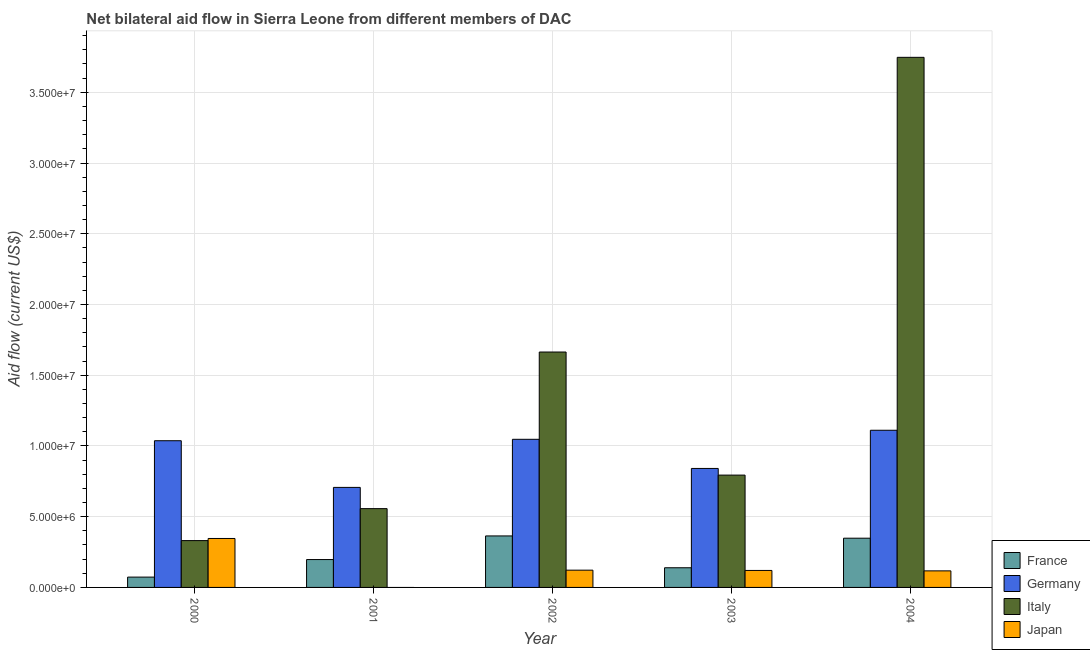How many groups of bars are there?
Ensure brevity in your answer.  5. Are the number of bars on each tick of the X-axis equal?
Your answer should be compact. No. How many bars are there on the 1st tick from the left?
Provide a short and direct response. 4. How many bars are there on the 5th tick from the right?
Make the answer very short. 4. What is the label of the 1st group of bars from the left?
Offer a very short reply. 2000. What is the amount of aid given by germany in 2003?
Offer a terse response. 8.41e+06. Across all years, what is the maximum amount of aid given by italy?
Give a very brief answer. 3.75e+07. Across all years, what is the minimum amount of aid given by italy?
Provide a succinct answer. 3.31e+06. In which year was the amount of aid given by japan maximum?
Your answer should be compact. 2000. What is the total amount of aid given by france in the graph?
Offer a very short reply. 1.12e+07. What is the difference between the amount of aid given by germany in 2002 and that in 2003?
Provide a short and direct response. 2.06e+06. What is the difference between the amount of aid given by japan in 2003 and the amount of aid given by france in 2002?
Offer a terse response. -2.00e+04. What is the average amount of aid given by italy per year?
Offer a terse response. 1.42e+07. In the year 2003, what is the difference between the amount of aid given by japan and amount of aid given by germany?
Your answer should be very brief. 0. What is the ratio of the amount of aid given by france in 2000 to that in 2004?
Offer a very short reply. 0.21. Is the amount of aid given by germany in 2003 less than that in 2004?
Provide a short and direct response. Yes. What is the difference between the highest and the second highest amount of aid given by italy?
Offer a very short reply. 2.08e+07. What is the difference between the highest and the lowest amount of aid given by japan?
Offer a terse response. 3.46e+06. Is it the case that in every year, the sum of the amount of aid given by france and amount of aid given by germany is greater than the amount of aid given by italy?
Your answer should be very brief. No. How many bars are there?
Give a very brief answer. 19. Are all the bars in the graph horizontal?
Your answer should be very brief. No. Does the graph contain any zero values?
Keep it short and to the point. Yes. Does the graph contain grids?
Keep it short and to the point. Yes. Where does the legend appear in the graph?
Your response must be concise. Bottom right. How many legend labels are there?
Keep it short and to the point. 4. What is the title of the graph?
Provide a succinct answer. Net bilateral aid flow in Sierra Leone from different members of DAC. What is the label or title of the X-axis?
Offer a terse response. Year. What is the Aid flow (current US$) of France in 2000?
Provide a short and direct response. 7.30e+05. What is the Aid flow (current US$) in Germany in 2000?
Provide a succinct answer. 1.04e+07. What is the Aid flow (current US$) of Italy in 2000?
Provide a succinct answer. 3.31e+06. What is the Aid flow (current US$) of Japan in 2000?
Give a very brief answer. 3.46e+06. What is the Aid flow (current US$) of France in 2001?
Offer a terse response. 1.97e+06. What is the Aid flow (current US$) of Germany in 2001?
Ensure brevity in your answer.  7.07e+06. What is the Aid flow (current US$) of Italy in 2001?
Your answer should be compact. 5.57e+06. What is the Aid flow (current US$) in France in 2002?
Ensure brevity in your answer.  3.64e+06. What is the Aid flow (current US$) of Germany in 2002?
Your response must be concise. 1.05e+07. What is the Aid flow (current US$) of Italy in 2002?
Your answer should be compact. 1.66e+07. What is the Aid flow (current US$) in Japan in 2002?
Your response must be concise. 1.22e+06. What is the Aid flow (current US$) in France in 2003?
Offer a very short reply. 1.39e+06. What is the Aid flow (current US$) in Germany in 2003?
Your answer should be compact. 8.41e+06. What is the Aid flow (current US$) of Italy in 2003?
Offer a very short reply. 7.94e+06. What is the Aid flow (current US$) of Japan in 2003?
Your response must be concise. 1.20e+06. What is the Aid flow (current US$) in France in 2004?
Make the answer very short. 3.48e+06. What is the Aid flow (current US$) in Germany in 2004?
Your response must be concise. 1.11e+07. What is the Aid flow (current US$) in Italy in 2004?
Make the answer very short. 3.75e+07. What is the Aid flow (current US$) of Japan in 2004?
Provide a succinct answer. 1.17e+06. Across all years, what is the maximum Aid flow (current US$) in France?
Ensure brevity in your answer.  3.64e+06. Across all years, what is the maximum Aid flow (current US$) in Germany?
Give a very brief answer. 1.11e+07. Across all years, what is the maximum Aid flow (current US$) of Italy?
Your response must be concise. 3.75e+07. Across all years, what is the maximum Aid flow (current US$) of Japan?
Your response must be concise. 3.46e+06. Across all years, what is the minimum Aid flow (current US$) in France?
Give a very brief answer. 7.30e+05. Across all years, what is the minimum Aid flow (current US$) of Germany?
Offer a terse response. 7.07e+06. Across all years, what is the minimum Aid flow (current US$) in Italy?
Provide a short and direct response. 3.31e+06. Across all years, what is the minimum Aid flow (current US$) of Japan?
Your answer should be compact. 0. What is the total Aid flow (current US$) in France in the graph?
Offer a very short reply. 1.12e+07. What is the total Aid flow (current US$) in Germany in the graph?
Your response must be concise. 4.74e+07. What is the total Aid flow (current US$) of Italy in the graph?
Your response must be concise. 7.09e+07. What is the total Aid flow (current US$) of Japan in the graph?
Keep it short and to the point. 7.05e+06. What is the difference between the Aid flow (current US$) of France in 2000 and that in 2001?
Make the answer very short. -1.24e+06. What is the difference between the Aid flow (current US$) of Germany in 2000 and that in 2001?
Your response must be concise. 3.30e+06. What is the difference between the Aid flow (current US$) of Italy in 2000 and that in 2001?
Provide a succinct answer. -2.26e+06. What is the difference between the Aid flow (current US$) in France in 2000 and that in 2002?
Your response must be concise. -2.91e+06. What is the difference between the Aid flow (current US$) in Italy in 2000 and that in 2002?
Keep it short and to the point. -1.33e+07. What is the difference between the Aid flow (current US$) in Japan in 2000 and that in 2002?
Provide a succinct answer. 2.24e+06. What is the difference between the Aid flow (current US$) of France in 2000 and that in 2003?
Make the answer very short. -6.60e+05. What is the difference between the Aid flow (current US$) in Germany in 2000 and that in 2003?
Your response must be concise. 1.96e+06. What is the difference between the Aid flow (current US$) in Italy in 2000 and that in 2003?
Your response must be concise. -4.63e+06. What is the difference between the Aid flow (current US$) in Japan in 2000 and that in 2003?
Offer a very short reply. 2.26e+06. What is the difference between the Aid flow (current US$) of France in 2000 and that in 2004?
Ensure brevity in your answer.  -2.75e+06. What is the difference between the Aid flow (current US$) in Germany in 2000 and that in 2004?
Ensure brevity in your answer.  -7.40e+05. What is the difference between the Aid flow (current US$) in Italy in 2000 and that in 2004?
Give a very brief answer. -3.42e+07. What is the difference between the Aid flow (current US$) of Japan in 2000 and that in 2004?
Your answer should be compact. 2.29e+06. What is the difference between the Aid flow (current US$) in France in 2001 and that in 2002?
Keep it short and to the point. -1.67e+06. What is the difference between the Aid flow (current US$) of Germany in 2001 and that in 2002?
Make the answer very short. -3.40e+06. What is the difference between the Aid flow (current US$) in Italy in 2001 and that in 2002?
Your answer should be compact. -1.11e+07. What is the difference between the Aid flow (current US$) in France in 2001 and that in 2003?
Your answer should be compact. 5.80e+05. What is the difference between the Aid flow (current US$) of Germany in 2001 and that in 2003?
Make the answer very short. -1.34e+06. What is the difference between the Aid flow (current US$) of Italy in 2001 and that in 2003?
Give a very brief answer. -2.37e+06. What is the difference between the Aid flow (current US$) in France in 2001 and that in 2004?
Give a very brief answer. -1.51e+06. What is the difference between the Aid flow (current US$) of Germany in 2001 and that in 2004?
Make the answer very short. -4.04e+06. What is the difference between the Aid flow (current US$) in Italy in 2001 and that in 2004?
Make the answer very short. -3.19e+07. What is the difference between the Aid flow (current US$) of France in 2002 and that in 2003?
Your answer should be very brief. 2.25e+06. What is the difference between the Aid flow (current US$) of Germany in 2002 and that in 2003?
Your answer should be very brief. 2.06e+06. What is the difference between the Aid flow (current US$) of Italy in 2002 and that in 2003?
Your answer should be very brief. 8.70e+06. What is the difference between the Aid flow (current US$) in Japan in 2002 and that in 2003?
Give a very brief answer. 2.00e+04. What is the difference between the Aid flow (current US$) in France in 2002 and that in 2004?
Offer a very short reply. 1.60e+05. What is the difference between the Aid flow (current US$) in Germany in 2002 and that in 2004?
Ensure brevity in your answer.  -6.40e+05. What is the difference between the Aid flow (current US$) of Italy in 2002 and that in 2004?
Offer a very short reply. -2.08e+07. What is the difference between the Aid flow (current US$) in Japan in 2002 and that in 2004?
Provide a succinct answer. 5.00e+04. What is the difference between the Aid flow (current US$) of France in 2003 and that in 2004?
Provide a short and direct response. -2.09e+06. What is the difference between the Aid flow (current US$) in Germany in 2003 and that in 2004?
Your response must be concise. -2.70e+06. What is the difference between the Aid flow (current US$) in Italy in 2003 and that in 2004?
Ensure brevity in your answer.  -2.95e+07. What is the difference between the Aid flow (current US$) in France in 2000 and the Aid flow (current US$) in Germany in 2001?
Provide a short and direct response. -6.34e+06. What is the difference between the Aid flow (current US$) in France in 2000 and the Aid flow (current US$) in Italy in 2001?
Offer a terse response. -4.84e+06. What is the difference between the Aid flow (current US$) in Germany in 2000 and the Aid flow (current US$) in Italy in 2001?
Your response must be concise. 4.80e+06. What is the difference between the Aid flow (current US$) of France in 2000 and the Aid flow (current US$) of Germany in 2002?
Make the answer very short. -9.74e+06. What is the difference between the Aid flow (current US$) in France in 2000 and the Aid flow (current US$) in Italy in 2002?
Keep it short and to the point. -1.59e+07. What is the difference between the Aid flow (current US$) in France in 2000 and the Aid flow (current US$) in Japan in 2002?
Provide a succinct answer. -4.90e+05. What is the difference between the Aid flow (current US$) in Germany in 2000 and the Aid flow (current US$) in Italy in 2002?
Make the answer very short. -6.27e+06. What is the difference between the Aid flow (current US$) of Germany in 2000 and the Aid flow (current US$) of Japan in 2002?
Your response must be concise. 9.15e+06. What is the difference between the Aid flow (current US$) of Italy in 2000 and the Aid flow (current US$) of Japan in 2002?
Offer a terse response. 2.09e+06. What is the difference between the Aid flow (current US$) of France in 2000 and the Aid flow (current US$) of Germany in 2003?
Your answer should be compact. -7.68e+06. What is the difference between the Aid flow (current US$) of France in 2000 and the Aid flow (current US$) of Italy in 2003?
Your response must be concise. -7.21e+06. What is the difference between the Aid flow (current US$) of France in 2000 and the Aid flow (current US$) of Japan in 2003?
Keep it short and to the point. -4.70e+05. What is the difference between the Aid flow (current US$) of Germany in 2000 and the Aid flow (current US$) of Italy in 2003?
Your response must be concise. 2.43e+06. What is the difference between the Aid flow (current US$) in Germany in 2000 and the Aid flow (current US$) in Japan in 2003?
Your response must be concise. 9.17e+06. What is the difference between the Aid flow (current US$) of Italy in 2000 and the Aid flow (current US$) of Japan in 2003?
Ensure brevity in your answer.  2.11e+06. What is the difference between the Aid flow (current US$) of France in 2000 and the Aid flow (current US$) of Germany in 2004?
Offer a terse response. -1.04e+07. What is the difference between the Aid flow (current US$) of France in 2000 and the Aid flow (current US$) of Italy in 2004?
Your response must be concise. -3.67e+07. What is the difference between the Aid flow (current US$) in France in 2000 and the Aid flow (current US$) in Japan in 2004?
Ensure brevity in your answer.  -4.40e+05. What is the difference between the Aid flow (current US$) of Germany in 2000 and the Aid flow (current US$) of Italy in 2004?
Keep it short and to the point. -2.71e+07. What is the difference between the Aid flow (current US$) of Germany in 2000 and the Aid flow (current US$) of Japan in 2004?
Provide a short and direct response. 9.20e+06. What is the difference between the Aid flow (current US$) of Italy in 2000 and the Aid flow (current US$) of Japan in 2004?
Your response must be concise. 2.14e+06. What is the difference between the Aid flow (current US$) of France in 2001 and the Aid flow (current US$) of Germany in 2002?
Make the answer very short. -8.50e+06. What is the difference between the Aid flow (current US$) of France in 2001 and the Aid flow (current US$) of Italy in 2002?
Give a very brief answer. -1.47e+07. What is the difference between the Aid flow (current US$) in France in 2001 and the Aid flow (current US$) in Japan in 2002?
Keep it short and to the point. 7.50e+05. What is the difference between the Aid flow (current US$) of Germany in 2001 and the Aid flow (current US$) of Italy in 2002?
Provide a succinct answer. -9.57e+06. What is the difference between the Aid flow (current US$) of Germany in 2001 and the Aid flow (current US$) of Japan in 2002?
Offer a terse response. 5.85e+06. What is the difference between the Aid flow (current US$) in Italy in 2001 and the Aid flow (current US$) in Japan in 2002?
Make the answer very short. 4.35e+06. What is the difference between the Aid flow (current US$) of France in 2001 and the Aid flow (current US$) of Germany in 2003?
Your answer should be compact. -6.44e+06. What is the difference between the Aid flow (current US$) of France in 2001 and the Aid flow (current US$) of Italy in 2003?
Ensure brevity in your answer.  -5.97e+06. What is the difference between the Aid flow (current US$) in France in 2001 and the Aid flow (current US$) in Japan in 2003?
Keep it short and to the point. 7.70e+05. What is the difference between the Aid flow (current US$) of Germany in 2001 and the Aid flow (current US$) of Italy in 2003?
Give a very brief answer. -8.70e+05. What is the difference between the Aid flow (current US$) in Germany in 2001 and the Aid flow (current US$) in Japan in 2003?
Your answer should be compact. 5.87e+06. What is the difference between the Aid flow (current US$) in Italy in 2001 and the Aid flow (current US$) in Japan in 2003?
Your answer should be compact. 4.37e+06. What is the difference between the Aid flow (current US$) of France in 2001 and the Aid flow (current US$) of Germany in 2004?
Your answer should be very brief. -9.14e+06. What is the difference between the Aid flow (current US$) of France in 2001 and the Aid flow (current US$) of Italy in 2004?
Your response must be concise. -3.55e+07. What is the difference between the Aid flow (current US$) in France in 2001 and the Aid flow (current US$) in Japan in 2004?
Make the answer very short. 8.00e+05. What is the difference between the Aid flow (current US$) of Germany in 2001 and the Aid flow (current US$) of Italy in 2004?
Your answer should be very brief. -3.04e+07. What is the difference between the Aid flow (current US$) in Germany in 2001 and the Aid flow (current US$) in Japan in 2004?
Make the answer very short. 5.90e+06. What is the difference between the Aid flow (current US$) of Italy in 2001 and the Aid flow (current US$) of Japan in 2004?
Your response must be concise. 4.40e+06. What is the difference between the Aid flow (current US$) in France in 2002 and the Aid flow (current US$) in Germany in 2003?
Make the answer very short. -4.77e+06. What is the difference between the Aid flow (current US$) in France in 2002 and the Aid flow (current US$) in Italy in 2003?
Keep it short and to the point. -4.30e+06. What is the difference between the Aid flow (current US$) of France in 2002 and the Aid flow (current US$) of Japan in 2003?
Keep it short and to the point. 2.44e+06. What is the difference between the Aid flow (current US$) in Germany in 2002 and the Aid flow (current US$) in Italy in 2003?
Give a very brief answer. 2.53e+06. What is the difference between the Aid flow (current US$) of Germany in 2002 and the Aid flow (current US$) of Japan in 2003?
Your answer should be very brief. 9.27e+06. What is the difference between the Aid flow (current US$) of Italy in 2002 and the Aid flow (current US$) of Japan in 2003?
Ensure brevity in your answer.  1.54e+07. What is the difference between the Aid flow (current US$) in France in 2002 and the Aid flow (current US$) in Germany in 2004?
Offer a very short reply. -7.47e+06. What is the difference between the Aid flow (current US$) in France in 2002 and the Aid flow (current US$) in Italy in 2004?
Give a very brief answer. -3.38e+07. What is the difference between the Aid flow (current US$) of France in 2002 and the Aid flow (current US$) of Japan in 2004?
Your answer should be very brief. 2.47e+06. What is the difference between the Aid flow (current US$) of Germany in 2002 and the Aid flow (current US$) of Italy in 2004?
Ensure brevity in your answer.  -2.70e+07. What is the difference between the Aid flow (current US$) of Germany in 2002 and the Aid flow (current US$) of Japan in 2004?
Provide a short and direct response. 9.30e+06. What is the difference between the Aid flow (current US$) of Italy in 2002 and the Aid flow (current US$) of Japan in 2004?
Give a very brief answer. 1.55e+07. What is the difference between the Aid flow (current US$) of France in 2003 and the Aid flow (current US$) of Germany in 2004?
Provide a short and direct response. -9.72e+06. What is the difference between the Aid flow (current US$) in France in 2003 and the Aid flow (current US$) in Italy in 2004?
Offer a very short reply. -3.61e+07. What is the difference between the Aid flow (current US$) in France in 2003 and the Aid flow (current US$) in Japan in 2004?
Give a very brief answer. 2.20e+05. What is the difference between the Aid flow (current US$) of Germany in 2003 and the Aid flow (current US$) of Italy in 2004?
Ensure brevity in your answer.  -2.91e+07. What is the difference between the Aid flow (current US$) in Germany in 2003 and the Aid flow (current US$) in Japan in 2004?
Offer a very short reply. 7.24e+06. What is the difference between the Aid flow (current US$) in Italy in 2003 and the Aid flow (current US$) in Japan in 2004?
Your response must be concise. 6.77e+06. What is the average Aid flow (current US$) of France per year?
Give a very brief answer. 2.24e+06. What is the average Aid flow (current US$) in Germany per year?
Give a very brief answer. 9.49e+06. What is the average Aid flow (current US$) of Italy per year?
Offer a very short reply. 1.42e+07. What is the average Aid flow (current US$) of Japan per year?
Offer a very short reply. 1.41e+06. In the year 2000, what is the difference between the Aid flow (current US$) of France and Aid flow (current US$) of Germany?
Offer a very short reply. -9.64e+06. In the year 2000, what is the difference between the Aid flow (current US$) in France and Aid flow (current US$) in Italy?
Ensure brevity in your answer.  -2.58e+06. In the year 2000, what is the difference between the Aid flow (current US$) in France and Aid flow (current US$) in Japan?
Your answer should be compact. -2.73e+06. In the year 2000, what is the difference between the Aid flow (current US$) in Germany and Aid flow (current US$) in Italy?
Your response must be concise. 7.06e+06. In the year 2000, what is the difference between the Aid flow (current US$) of Germany and Aid flow (current US$) of Japan?
Keep it short and to the point. 6.91e+06. In the year 2000, what is the difference between the Aid flow (current US$) in Italy and Aid flow (current US$) in Japan?
Provide a short and direct response. -1.50e+05. In the year 2001, what is the difference between the Aid flow (current US$) of France and Aid flow (current US$) of Germany?
Your answer should be very brief. -5.10e+06. In the year 2001, what is the difference between the Aid flow (current US$) of France and Aid flow (current US$) of Italy?
Your answer should be compact. -3.60e+06. In the year 2001, what is the difference between the Aid flow (current US$) in Germany and Aid flow (current US$) in Italy?
Keep it short and to the point. 1.50e+06. In the year 2002, what is the difference between the Aid flow (current US$) of France and Aid flow (current US$) of Germany?
Offer a very short reply. -6.83e+06. In the year 2002, what is the difference between the Aid flow (current US$) of France and Aid flow (current US$) of Italy?
Offer a terse response. -1.30e+07. In the year 2002, what is the difference between the Aid flow (current US$) of France and Aid flow (current US$) of Japan?
Your answer should be very brief. 2.42e+06. In the year 2002, what is the difference between the Aid flow (current US$) of Germany and Aid flow (current US$) of Italy?
Your answer should be very brief. -6.17e+06. In the year 2002, what is the difference between the Aid flow (current US$) of Germany and Aid flow (current US$) of Japan?
Give a very brief answer. 9.25e+06. In the year 2002, what is the difference between the Aid flow (current US$) in Italy and Aid flow (current US$) in Japan?
Your answer should be compact. 1.54e+07. In the year 2003, what is the difference between the Aid flow (current US$) in France and Aid flow (current US$) in Germany?
Provide a short and direct response. -7.02e+06. In the year 2003, what is the difference between the Aid flow (current US$) in France and Aid flow (current US$) in Italy?
Keep it short and to the point. -6.55e+06. In the year 2003, what is the difference between the Aid flow (current US$) in Germany and Aid flow (current US$) in Italy?
Your answer should be compact. 4.70e+05. In the year 2003, what is the difference between the Aid flow (current US$) of Germany and Aid flow (current US$) of Japan?
Provide a short and direct response. 7.21e+06. In the year 2003, what is the difference between the Aid flow (current US$) of Italy and Aid flow (current US$) of Japan?
Ensure brevity in your answer.  6.74e+06. In the year 2004, what is the difference between the Aid flow (current US$) in France and Aid flow (current US$) in Germany?
Provide a short and direct response. -7.63e+06. In the year 2004, what is the difference between the Aid flow (current US$) in France and Aid flow (current US$) in Italy?
Make the answer very short. -3.40e+07. In the year 2004, what is the difference between the Aid flow (current US$) in France and Aid flow (current US$) in Japan?
Offer a terse response. 2.31e+06. In the year 2004, what is the difference between the Aid flow (current US$) of Germany and Aid flow (current US$) of Italy?
Your answer should be very brief. -2.64e+07. In the year 2004, what is the difference between the Aid flow (current US$) in Germany and Aid flow (current US$) in Japan?
Offer a very short reply. 9.94e+06. In the year 2004, what is the difference between the Aid flow (current US$) of Italy and Aid flow (current US$) of Japan?
Give a very brief answer. 3.63e+07. What is the ratio of the Aid flow (current US$) in France in 2000 to that in 2001?
Keep it short and to the point. 0.37. What is the ratio of the Aid flow (current US$) of Germany in 2000 to that in 2001?
Make the answer very short. 1.47. What is the ratio of the Aid flow (current US$) of Italy in 2000 to that in 2001?
Provide a succinct answer. 0.59. What is the ratio of the Aid flow (current US$) in France in 2000 to that in 2002?
Your answer should be compact. 0.2. What is the ratio of the Aid flow (current US$) in Italy in 2000 to that in 2002?
Offer a very short reply. 0.2. What is the ratio of the Aid flow (current US$) in Japan in 2000 to that in 2002?
Make the answer very short. 2.84. What is the ratio of the Aid flow (current US$) of France in 2000 to that in 2003?
Offer a terse response. 0.53. What is the ratio of the Aid flow (current US$) of Germany in 2000 to that in 2003?
Give a very brief answer. 1.23. What is the ratio of the Aid flow (current US$) of Italy in 2000 to that in 2003?
Provide a succinct answer. 0.42. What is the ratio of the Aid flow (current US$) in Japan in 2000 to that in 2003?
Your answer should be compact. 2.88. What is the ratio of the Aid flow (current US$) of France in 2000 to that in 2004?
Keep it short and to the point. 0.21. What is the ratio of the Aid flow (current US$) in Germany in 2000 to that in 2004?
Keep it short and to the point. 0.93. What is the ratio of the Aid flow (current US$) of Italy in 2000 to that in 2004?
Your answer should be very brief. 0.09. What is the ratio of the Aid flow (current US$) of Japan in 2000 to that in 2004?
Your answer should be very brief. 2.96. What is the ratio of the Aid flow (current US$) in France in 2001 to that in 2002?
Provide a succinct answer. 0.54. What is the ratio of the Aid flow (current US$) in Germany in 2001 to that in 2002?
Your answer should be compact. 0.68. What is the ratio of the Aid flow (current US$) of Italy in 2001 to that in 2002?
Ensure brevity in your answer.  0.33. What is the ratio of the Aid flow (current US$) of France in 2001 to that in 2003?
Your answer should be very brief. 1.42. What is the ratio of the Aid flow (current US$) in Germany in 2001 to that in 2003?
Make the answer very short. 0.84. What is the ratio of the Aid flow (current US$) in Italy in 2001 to that in 2003?
Your answer should be compact. 0.7. What is the ratio of the Aid flow (current US$) in France in 2001 to that in 2004?
Your answer should be very brief. 0.57. What is the ratio of the Aid flow (current US$) in Germany in 2001 to that in 2004?
Keep it short and to the point. 0.64. What is the ratio of the Aid flow (current US$) in Italy in 2001 to that in 2004?
Give a very brief answer. 0.15. What is the ratio of the Aid flow (current US$) of France in 2002 to that in 2003?
Your response must be concise. 2.62. What is the ratio of the Aid flow (current US$) of Germany in 2002 to that in 2003?
Keep it short and to the point. 1.24. What is the ratio of the Aid flow (current US$) in Italy in 2002 to that in 2003?
Offer a terse response. 2.1. What is the ratio of the Aid flow (current US$) of Japan in 2002 to that in 2003?
Provide a short and direct response. 1.02. What is the ratio of the Aid flow (current US$) in France in 2002 to that in 2004?
Offer a terse response. 1.05. What is the ratio of the Aid flow (current US$) in Germany in 2002 to that in 2004?
Offer a terse response. 0.94. What is the ratio of the Aid flow (current US$) of Italy in 2002 to that in 2004?
Your response must be concise. 0.44. What is the ratio of the Aid flow (current US$) of Japan in 2002 to that in 2004?
Provide a short and direct response. 1.04. What is the ratio of the Aid flow (current US$) of France in 2003 to that in 2004?
Keep it short and to the point. 0.4. What is the ratio of the Aid flow (current US$) of Germany in 2003 to that in 2004?
Offer a terse response. 0.76. What is the ratio of the Aid flow (current US$) in Italy in 2003 to that in 2004?
Offer a very short reply. 0.21. What is the ratio of the Aid flow (current US$) in Japan in 2003 to that in 2004?
Give a very brief answer. 1.03. What is the difference between the highest and the second highest Aid flow (current US$) in Germany?
Offer a very short reply. 6.40e+05. What is the difference between the highest and the second highest Aid flow (current US$) in Italy?
Provide a short and direct response. 2.08e+07. What is the difference between the highest and the second highest Aid flow (current US$) of Japan?
Provide a succinct answer. 2.24e+06. What is the difference between the highest and the lowest Aid flow (current US$) in France?
Ensure brevity in your answer.  2.91e+06. What is the difference between the highest and the lowest Aid flow (current US$) in Germany?
Offer a very short reply. 4.04e+06. What is the difference between the highest and the lowest Aid flow (current US$) in Italy?
Make the answer very short. 3.42e+07. What is the difference between the highest and the lowest Aid flow (current US$) of Japan?
Your answer should be compact. 3.46e+06. 